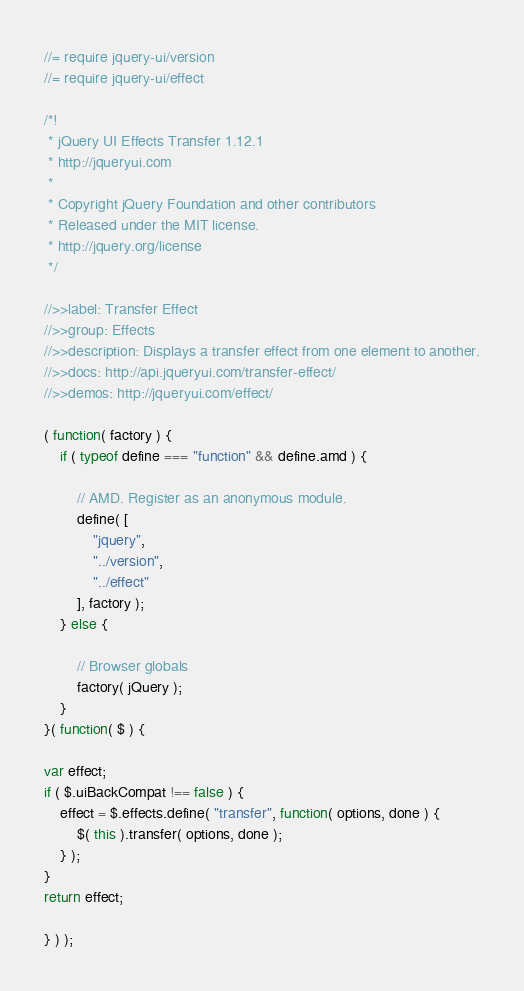Convert code to text. <code><loc_0><loc_0><loc_500><loc_500><_JavaScript_>//= require jquery-ui/version
//= require jquery-ui/effect

/*!
 * jQuery UI Effects Transfer 1.12.1
 * http://jqueryui.com
 *
 * Copyright jQuery Foundation and other contributors
 * Released under the MIT license.
 * http://jquery.org/license
 */

//>>label: Transfer Effect
//>>group: Effects
//>>description: Displays a transfer effect from one element to another.
//>>docs: http://api.jqueryui.com/transfer-effect/
//>>demos: http://jqueryui.com/effect/

( function( factory ) {
	if ( typeof define === "function" && define.amd ) {

		// AMD. Register as an anonymous module.
		define( [
			"jquery",
			"../version",
			"../effect"
		], factory );
	} else {

		// Browser globals
		factory( jQuery );
	}
}( function( $ ) {

var effect;
if ( $.uiBackCompat !== false ) {
	effect = $.effects.define( "transfer", function( options, done ) {
		$( this ).transfer( options, done );
	} );
}
return effect;

} ) );
</code> 